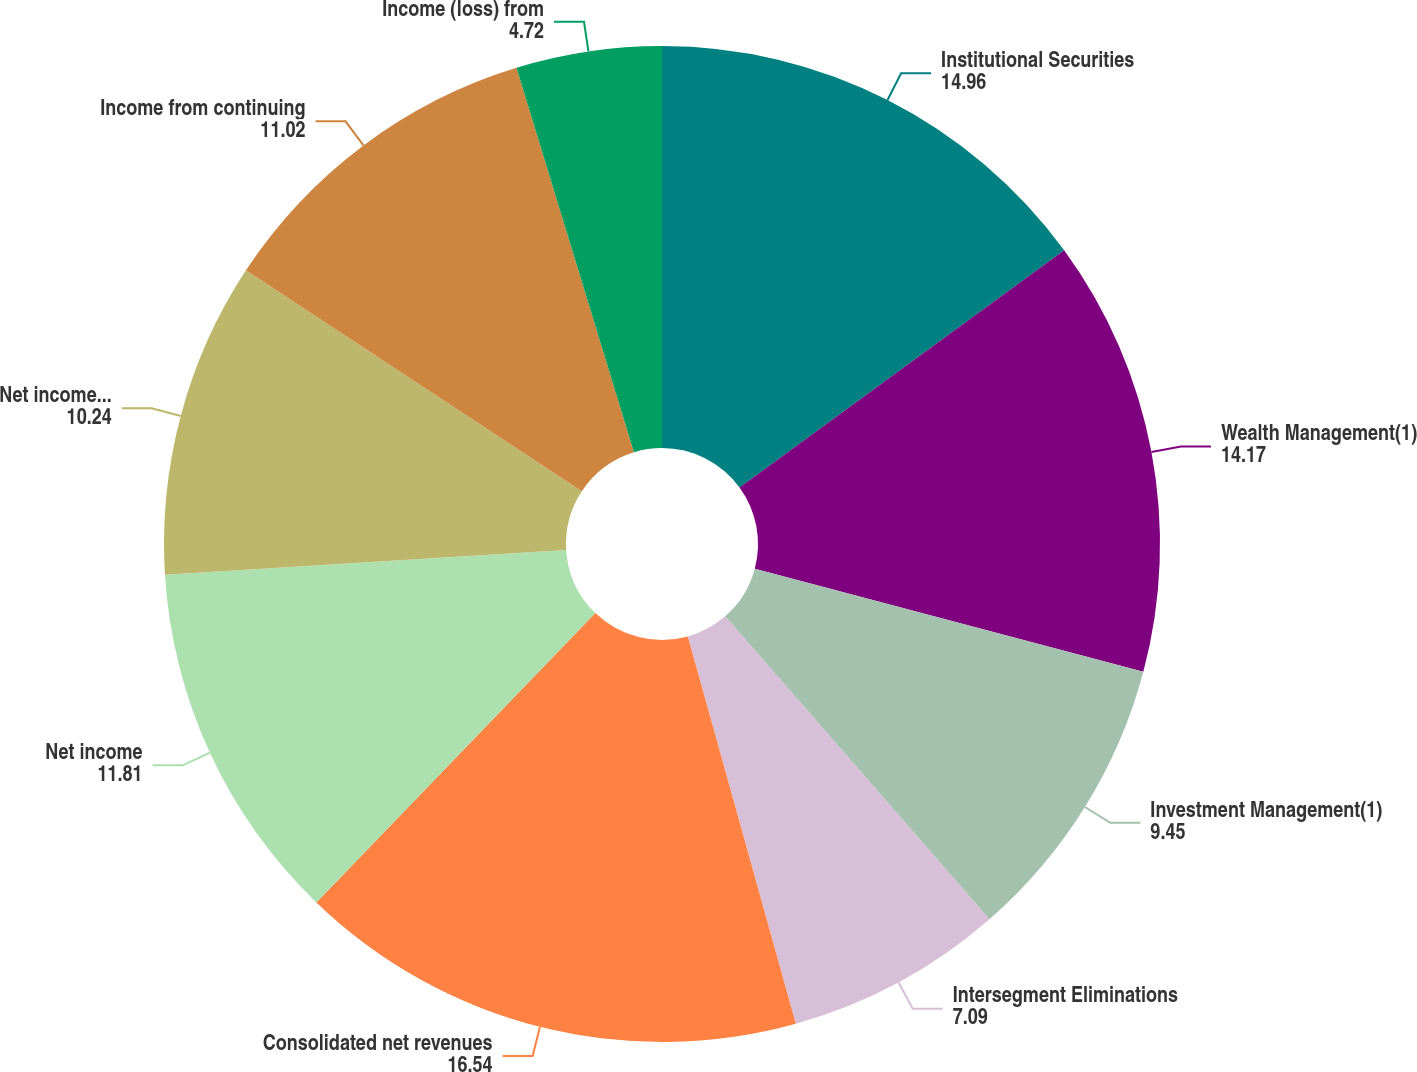Convert chart. <chart><loc_0><loc_0><loc_500><loc_500><pie_chart><fcel>Institutional Securities<fcel>Wealth Management(1)<fcel>Investment Management(1)<fcel>Intersegment Eliminations<fcel>Consolidated net revenues<fcel>Net income<fcel>Net income applicable to<fcel>Income from continuing<fcel>Income (loss) from<nl><fcel>14.96%<fcel>14.17%<fcel>9.45%<fcel>7.09%<fcel>16.54%<fcel>11.81%<fcel>10.24%<fcel>11.02%<fcel>4.72%<nl></chart> 